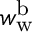Convert formula to latex. <formula><loc_0><loc_0><loc_500><loc_500>w _ { w } ^ { b }</formula> 